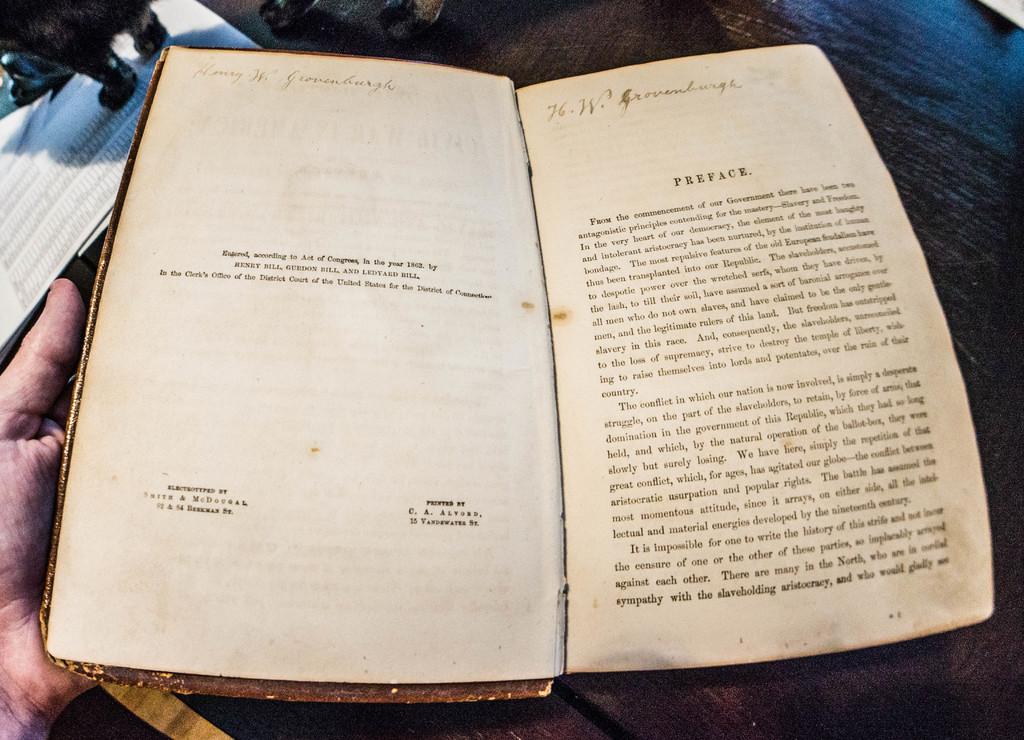What page is the book open to?
Make the answer very short. Unanswerable. What is the first line wrote on the right side of the book?
Make the answer very short. Preface. 